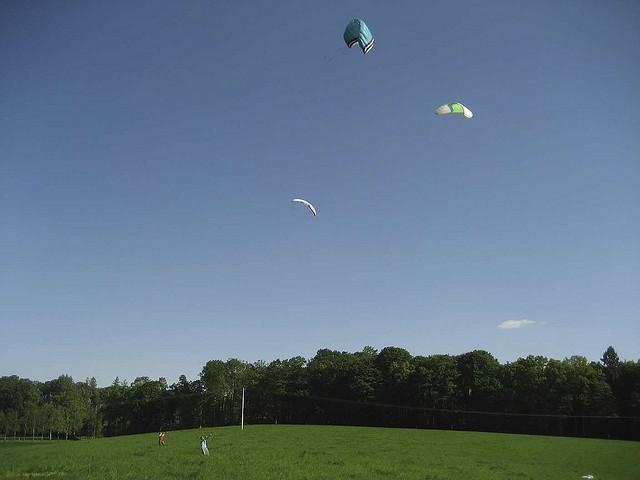The flying objects are made of what material?
From the following four choices, select the correct answer to address the question.
Options: Polyester, copper, aluminum, paper. Polyester. 